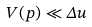Convert formula to latex. <formula><loc_0><loc_0><loc_500><loc_500>V ( p ) \ll \Delta u</formula> 